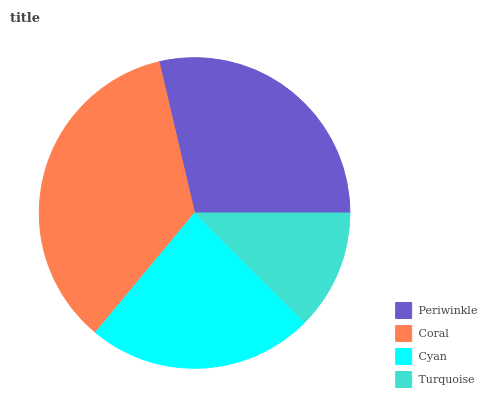Is Turquoise the minimum?
Answer yes or no. Yes. Is Coral the maximum?
Answer yes or no. Yes. Is Cyan the minimum?
Answer yes or no. No. Is Cyan the maximum?
Answer yes or no. No. Is Coral greater than Cyan?
Answer yes or no. Yes. Is Cyan less than Coral?
Answer yes or no. Yes. Is Cyan greater than Coral?
Answer yes or no. No. Is Coral less than Cyan?
Answer yes or no. No. Is Periwinkle the high median?
Answer yes or no. Yes. Is Cyan the low median?
Answer yes or no. Yes. Is Coral the high median?
Answer yes or no. No. Is Periwinkle the low median?
Answer yes or no. No. 